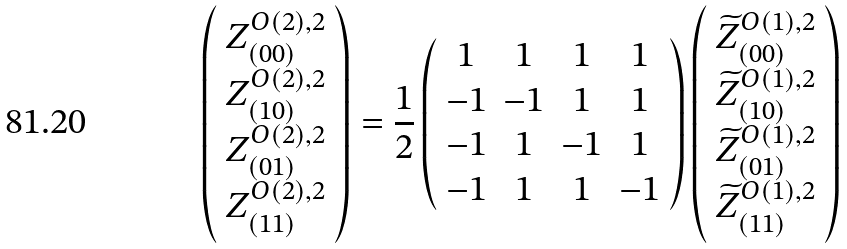<formula> <loc_0><loc_0><loc_500><loc_500>\left ( \begin{array} { c } Z ^ { O ( 2 ) , 2 } _ { ( 0 0 ) } \\ Z ^ { O ( 2 ) , 2 } _ { ( 1 0 ) } \\ Z ^ { O ( 2 ) , 2 } _ { ( 0 1 ) } \\ Z ^ { O ( 2 ) , 2 } _ { ( 1 1 ) } \\ \end{array} \right ) = \frac { 1 } { 2 } \left ( \begin{array} { c c c c } 1 & 1 & 1 & 1 \\ - 1 & - 1 & 1 & 1 \\ - 1 & 1 & - 1 & 1 \\ - 1 & 1 & 1 & - 1 \\ \end{array} \right ) \left ( \begin{array} { c } \widetilde { Z } ^ { O ( 1 ) , 2 } _ { ( 0 0 ) } \\ \widetilde { Z } ^ { O ( 1 ) , 2 } _ { ( 1 0 ) } \\ \widetilde { Z } ^ { O ( 1 ) , 2 } _ { ( 0 1 ) } \\ \widetilde { Z } ^ { O ( 1 ) , 2 } _ { ( 1 1 ) } \\ \end{array} \right )</formula> 